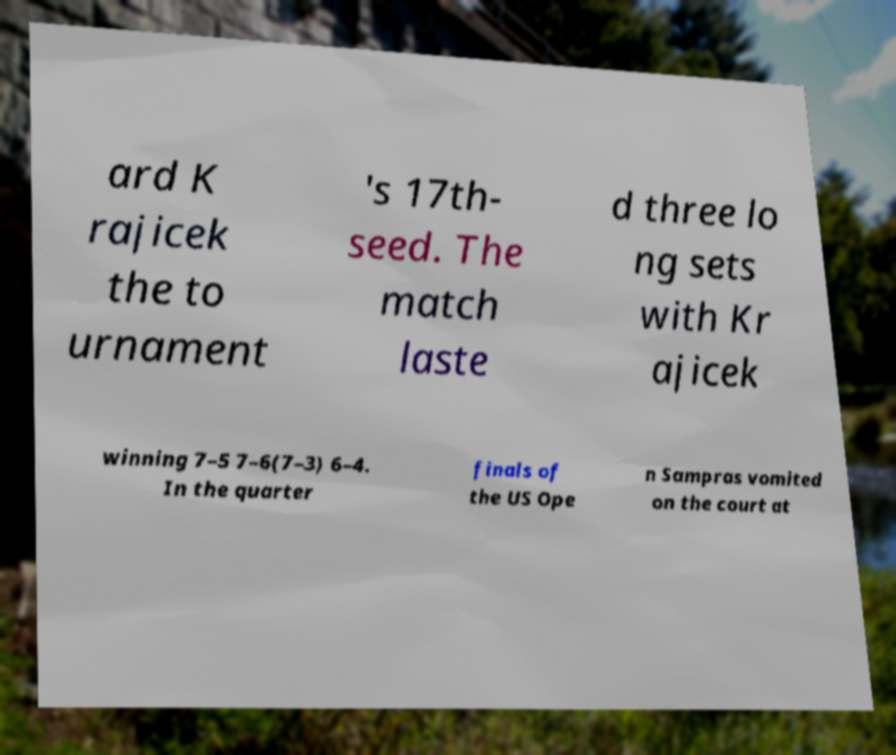Can you read and provide the text displayed in the image?This photo seems to have some interesting text. Can you extract and type it out for me? ard K rajicek the to urnament 's 17th- seed. The match laste d three lo ng sets with Kr ajicek winning 7–5 7–6(7–3) 6–4. In the quarter finals of the US Ope n Sampras vomited on the court at 